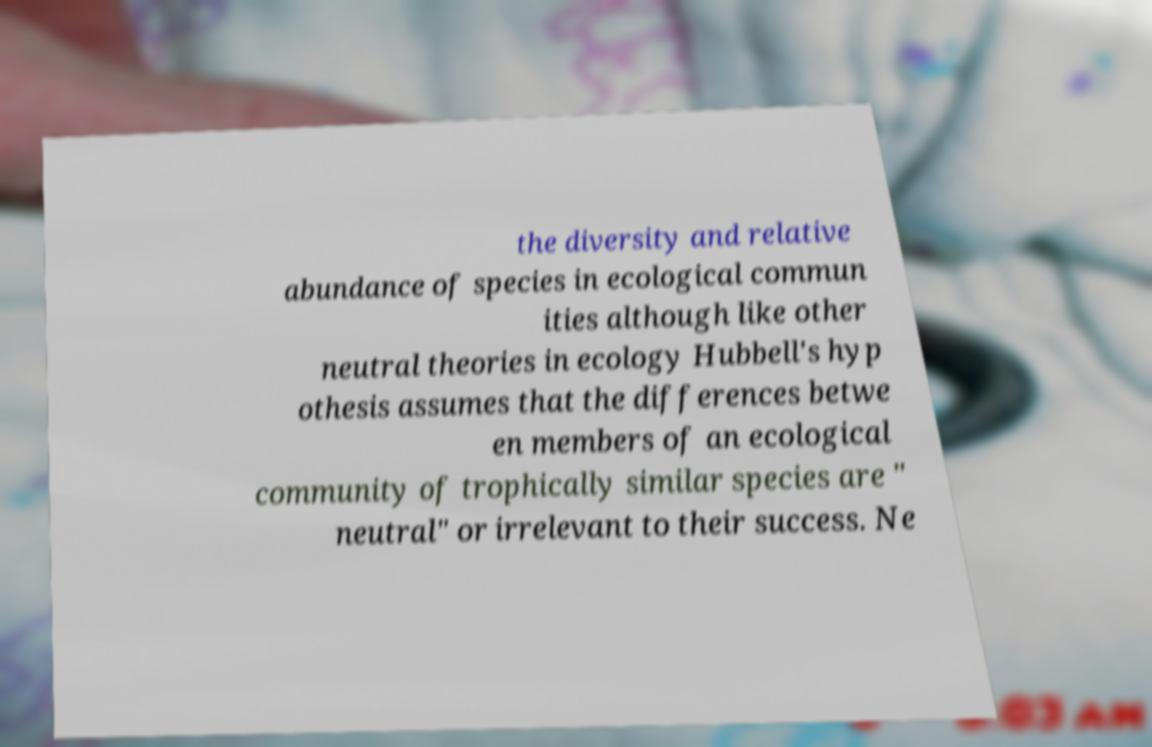For documentation purposes, I need the text within this image transcribed. Could you provide that? the diversity and relative abundance of species in ecological commun ities although like other neutral theories in ecology Hubbell's hyp othesis assumes that the differences betwe en members of an ecological community of trophically similar species are " neutral" or irrelevant to their success. Ne 